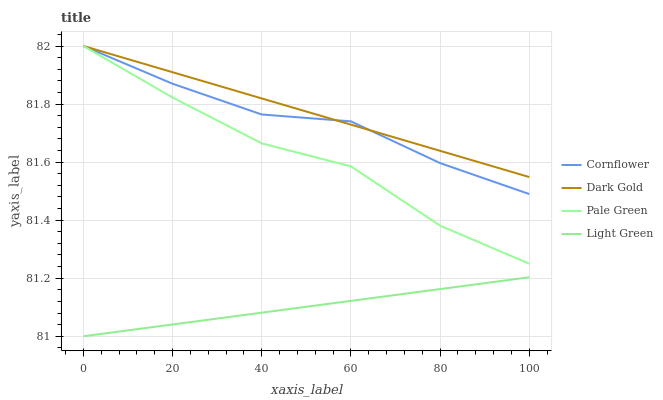Does Light Green have the minimum area under the curve?
Answer yes or no. Yes. Does Dark Gold have the maximum area under the curve?
Answer yes or no. Yes. Does Pale Green have the minimum area under the curve?
Answer yes or no. No. Does Pale Green have the maximum area under the curve?
Answer yes or no. No. Is Light Green the smoothest?
Answer yes or no. Yes. Is Pale Green the roughest?
Answer yes or no. Yes. Is Pale Green the smoothest?
Answer yes or no. No. Is Light Green the roughest?
Answer yes or no. No. Does Light Green have the lowest value?
Answer yes or no. Yes. Does Pale Green have the lowest value?
Answer yes or no. No. Does Dark Gold have the highest value?
Answer yes or no. Yes. Does Light Green have the highest value?
Answer yes or no. No. Is Light Green less than Pale Green?
Answer yes or no. Yes. Is Pale Green greater than Light Green?
Answer yes or no. Yes. Does Dark Gold intersect Cornflower?
Answer yes or no. Yes. Is Dark Gold less than Cornflower?
Answer yes or no. No. Is Dark Gold greater than Cornflower?
Answer yes or no. No. Does Light Green intersect Pale Green?
Answer yes or no. No. 